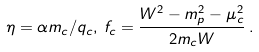Convert formula to latex. <formula><loc_0><loc_0><loc_500><loc_500>\eta = \alpha m _ { c } / q _ { c } , \, f _ { c } = \frac { W ^ { 2 } - m _ { p } ^ { 2 } - \mu _ { c } ^ { 2 } } { 2 m _ { c } W } \, .</formula> 